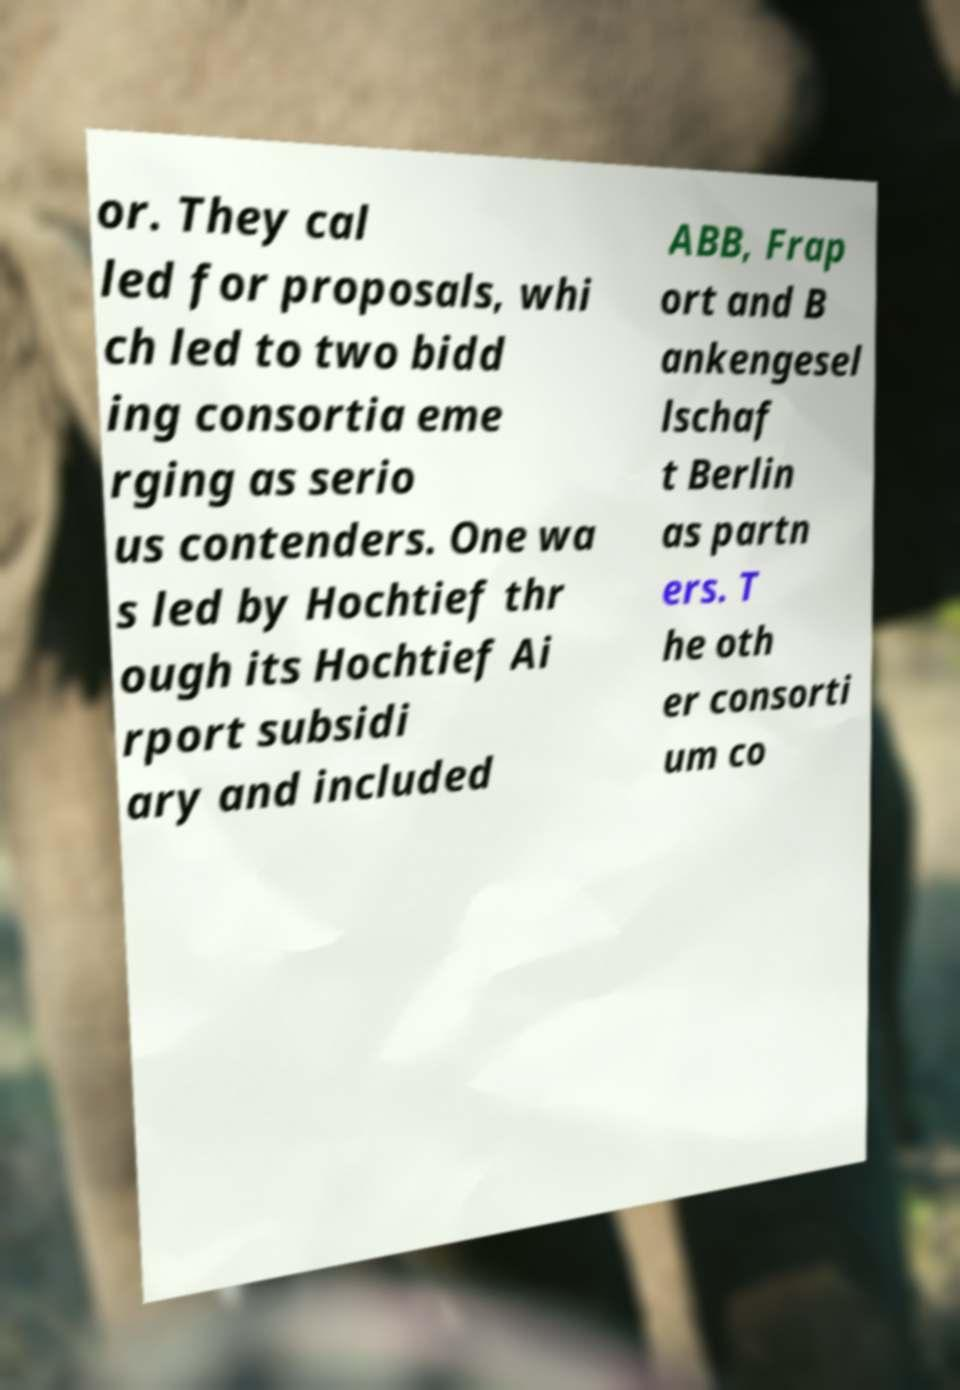Can you accurately transcribe the text from the provided image for me? or. They cal led for proposals, whi ch led to two bidd ing consortia eme rging as serio us contenders. One wa s led by Hochtief thr ough its Hochtief Ai rport subsidi ary and included ABB, Frap ort and B ankengesel lschaf t Berlin as partn ers. T he oth er consorti um co 